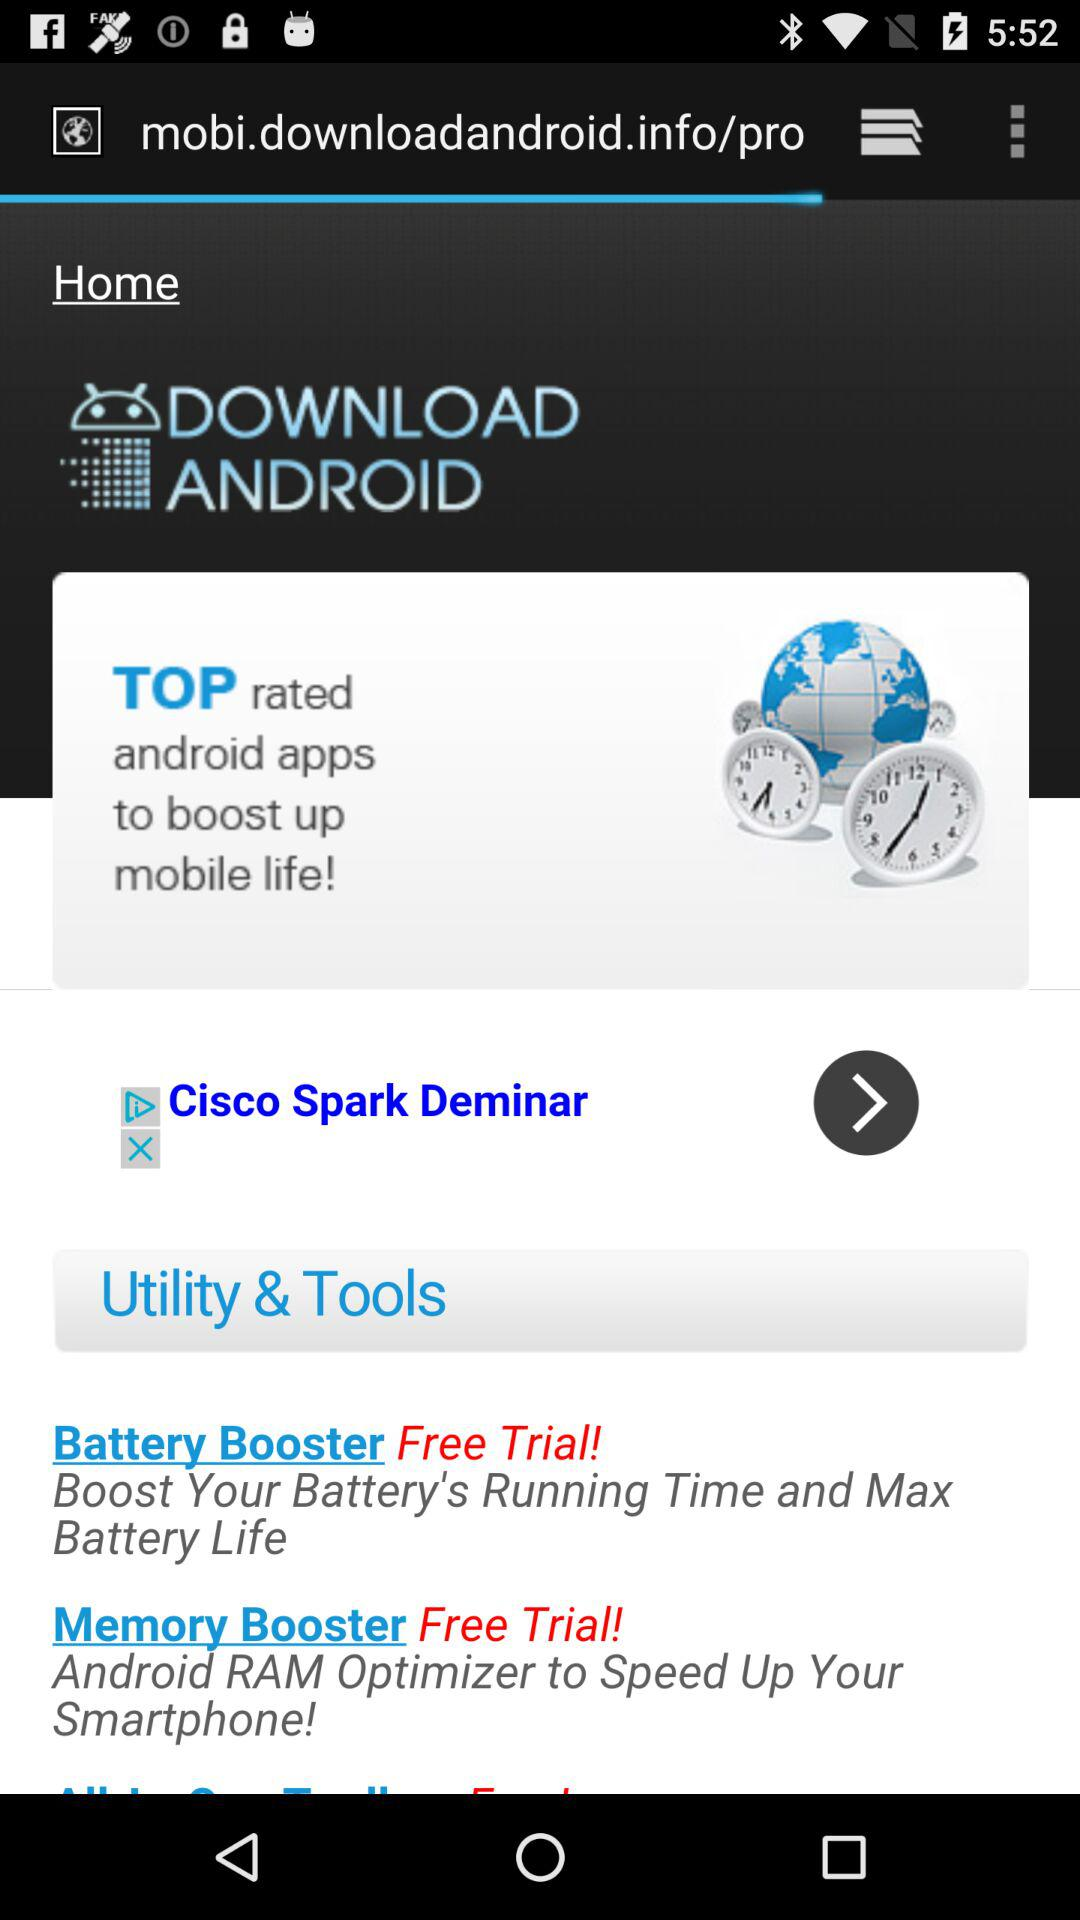Which booster boosts the battery's running time and maximizes battery life? The booster that boosts the battery's running time and maximizes battery life is "Battery Booster". 